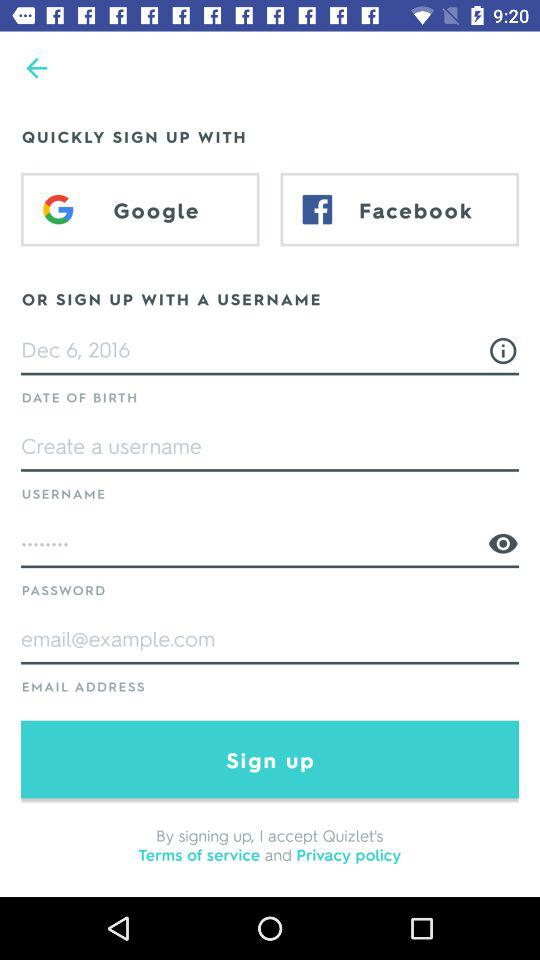What is the date of birth? The date of birth is December 6, 2016. 